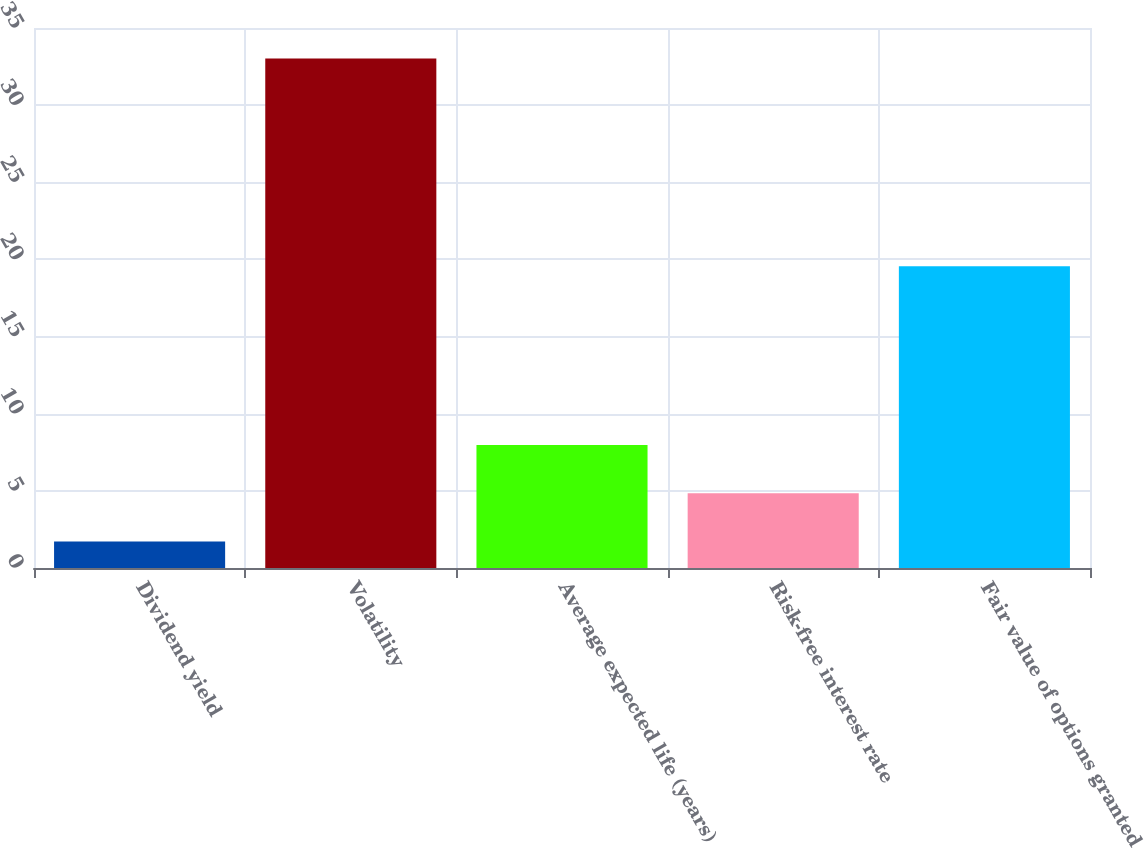Convert chart. <chart><loc_0><loc_0><loc_500><loc_500><bar_chart><fcel>Dividend yield<fcel>Volatility<fcel>Average expected life (years)<fcel>Risk-free interest rate<fcel>Fair value of options granted<nl><fcel>1.71<fcel>33.03<fcel>7.97<fcel>4.84<fcel>19.56<nl></chart> 